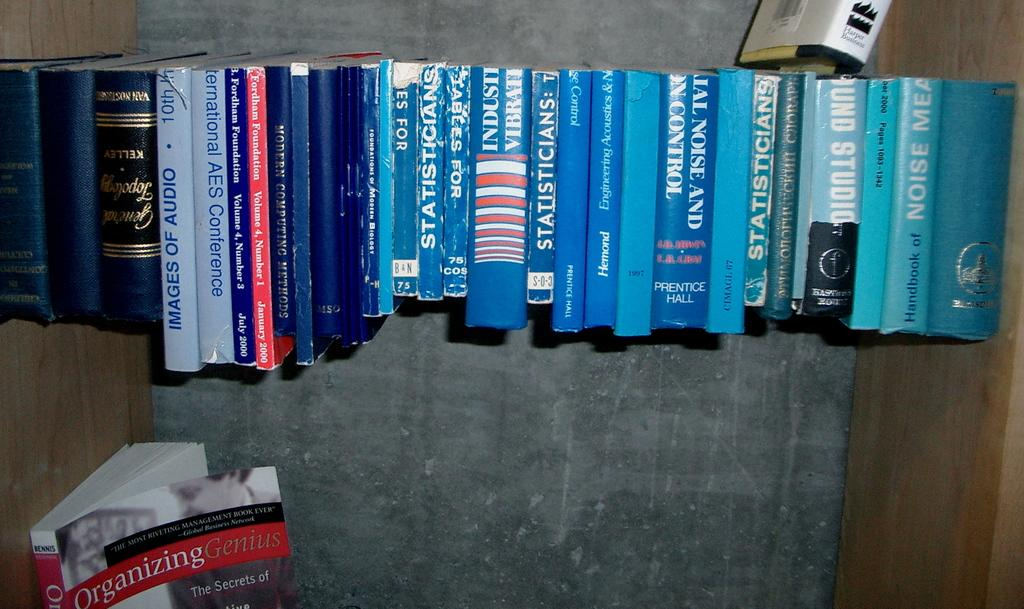<image>
Write a terse but informative summary of the picture. blue books lined up on the floor include Statisticians 